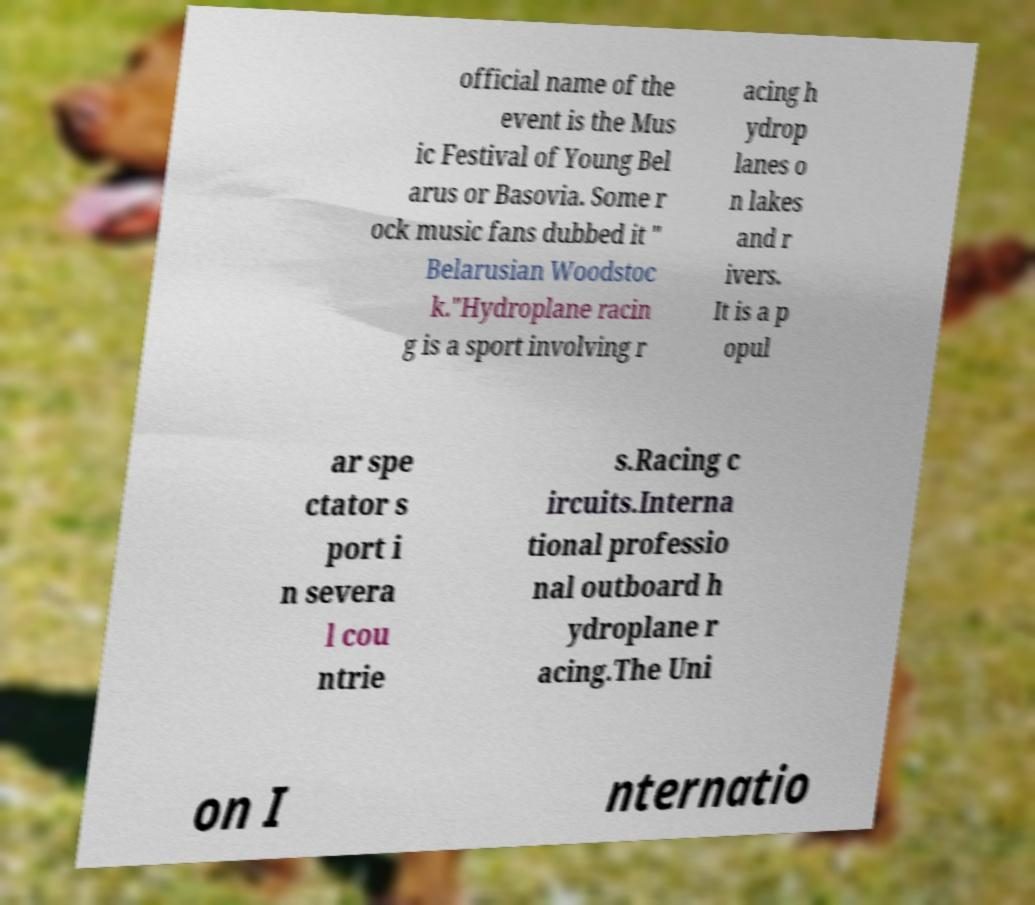Can you read and provide the text displayed in the image?This photo seems to have some interesting text. Can you extract and type it out for me? official name of the event is the Mus ic Festival of Young Bel arus or Basovia. Some r ock music fans dubbed it " Belarusian Woodstoc k."Hydroplane racin g is a sport involving r acing h ydrop lanes o n lakes and r ivers. It is a p opul ar spe ctator s port i n severa l cou ntrie s.Racing c ircuits.Interna tional professio nal outboard h ydroplane r acing.The Uni on I nternatio 